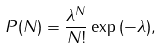<formula> <loc_0><loc_0><loc_500><loc_500>P ( N ) = \frac { \lambda ^ { N } } { N ! } \exp { ( - \lambda ) } ,</formula> 